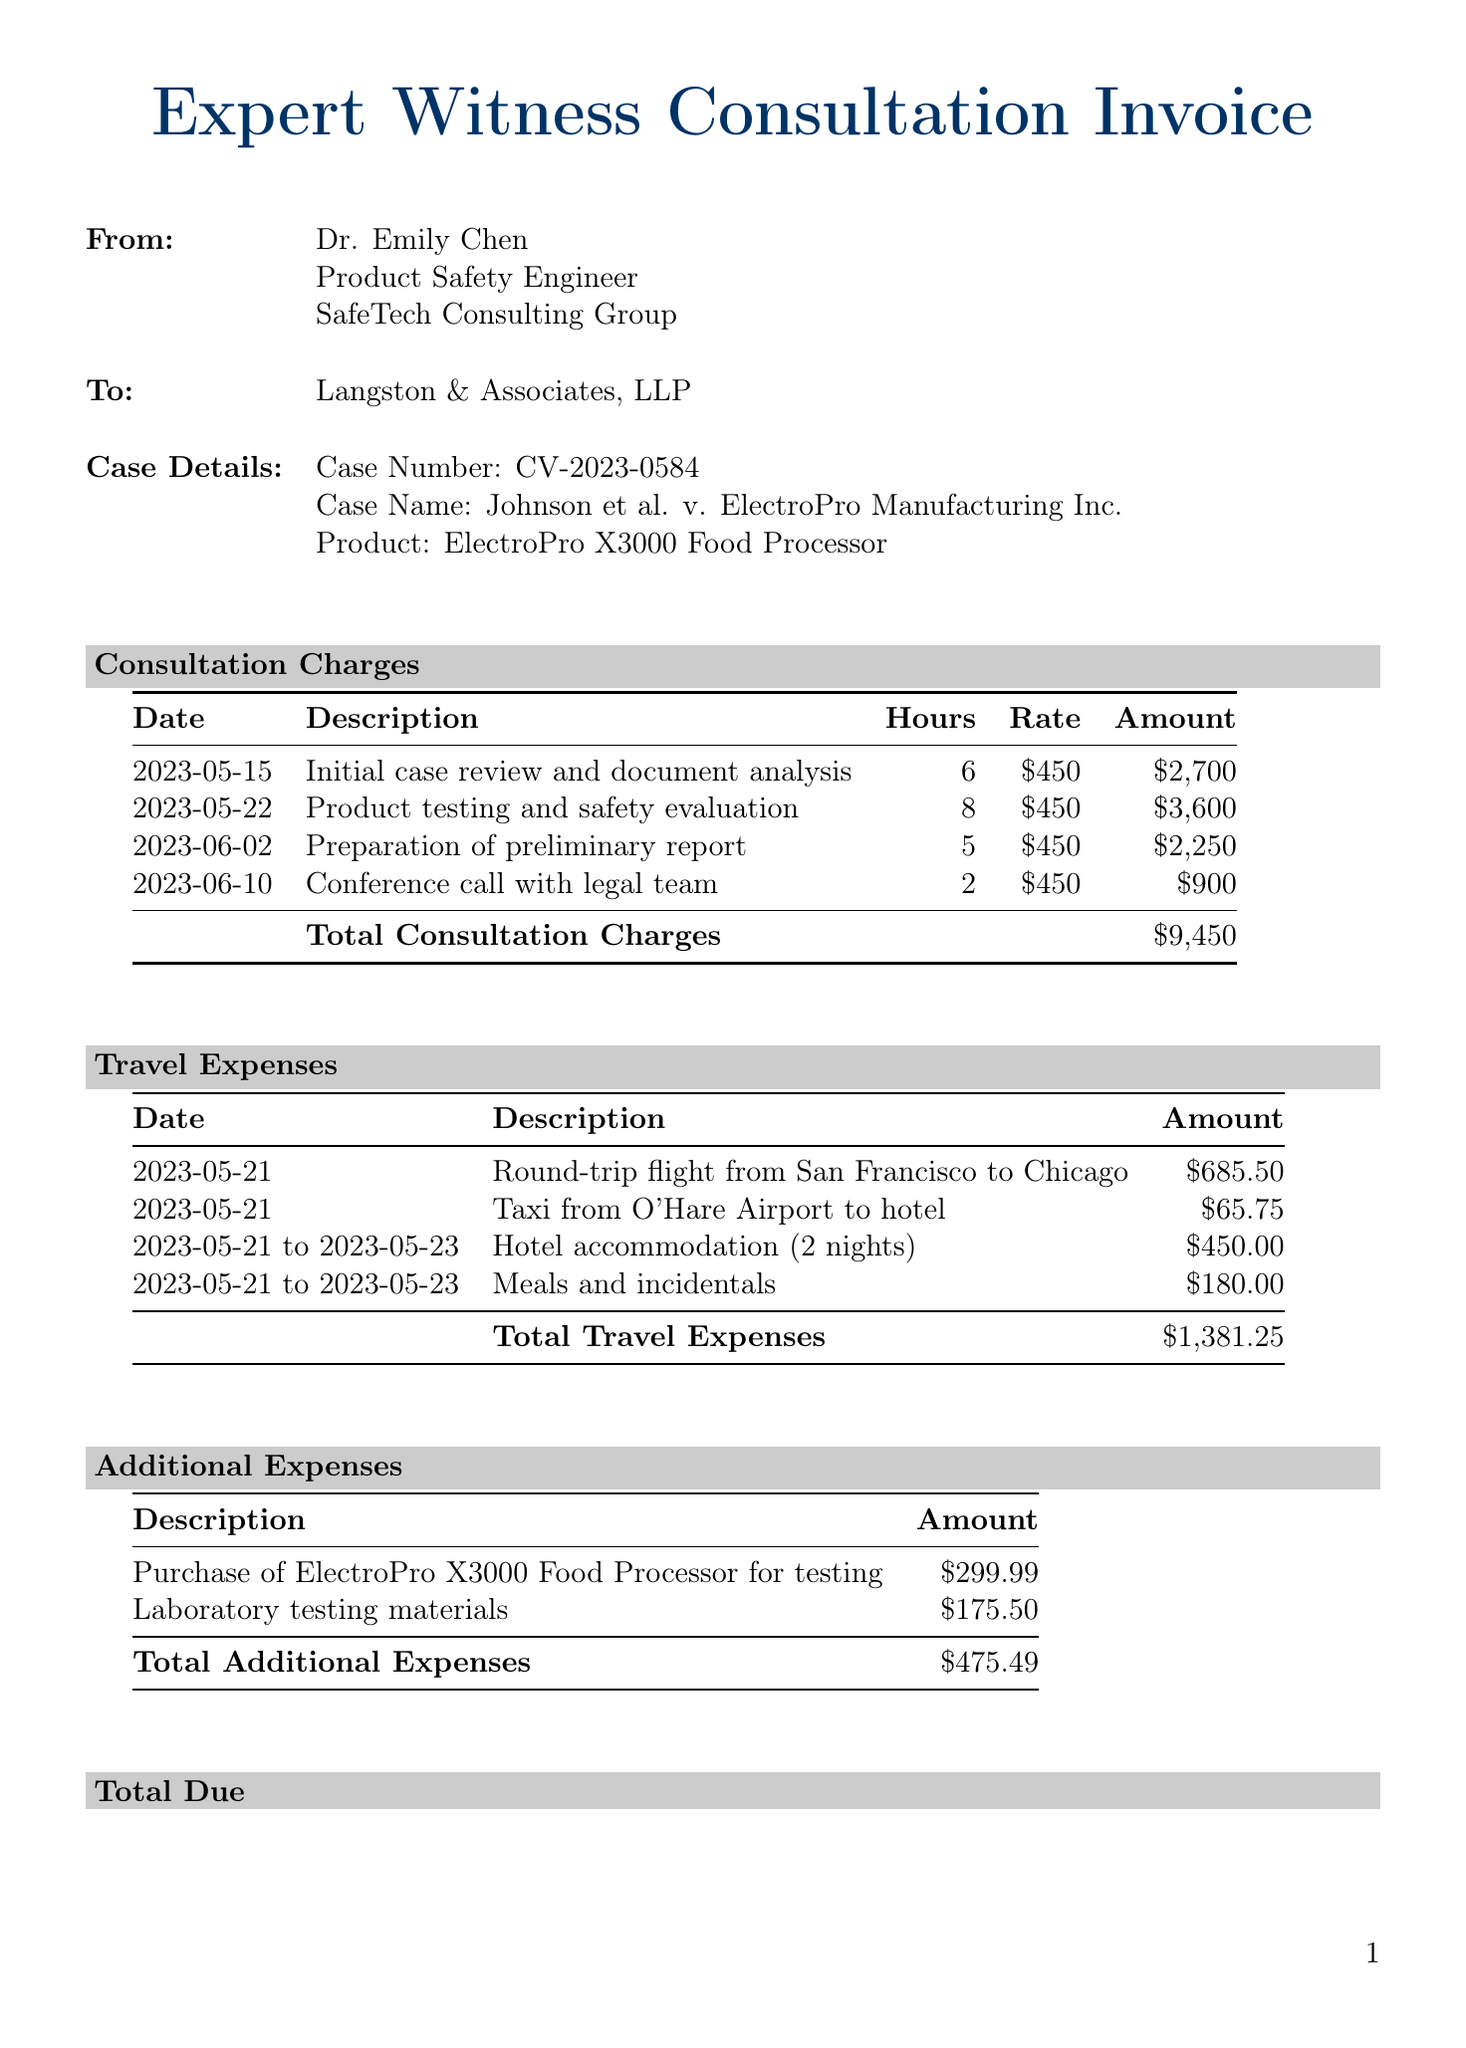What is the name of the expert witness? The name of the expert witness is listed in the document as Dr. Emily Chen.
Answer: Dr. Emily Chen What is the case number? The case number is specified in the case details section of the document.
Answer: CV-2023-0584 How many hours were billed for the product testing and safety evaluation? The hours billed for this service are noted in the consultation charges section.
Answer: 8 What is the total amount for consultation charges? The total amount is the sum of all consultation charges listed in the document.
Answer: $9,450 What are the total travel expenses? The total travel expenses are provided in the travel expenses section of the invoice.
Answer: $1,381.25 When is the payment due? The due date for payment is explicitly stated in the payment terms section.
Answer: July 15, 2023 What is the amount for the purchase of the product for testing? The amount for this expense is mentioned in the additional expenses section.
Answer: $299.99 What is the total due for the invoice? The total due is calculated from the various charges and is presented at the bottom of the invoice.
Answer: $11,306.74 What is the late payment fee charged on unpaid balances? The late payment fee details are outlined in the payment terms section of the document.
Answer: 1.5% per month 